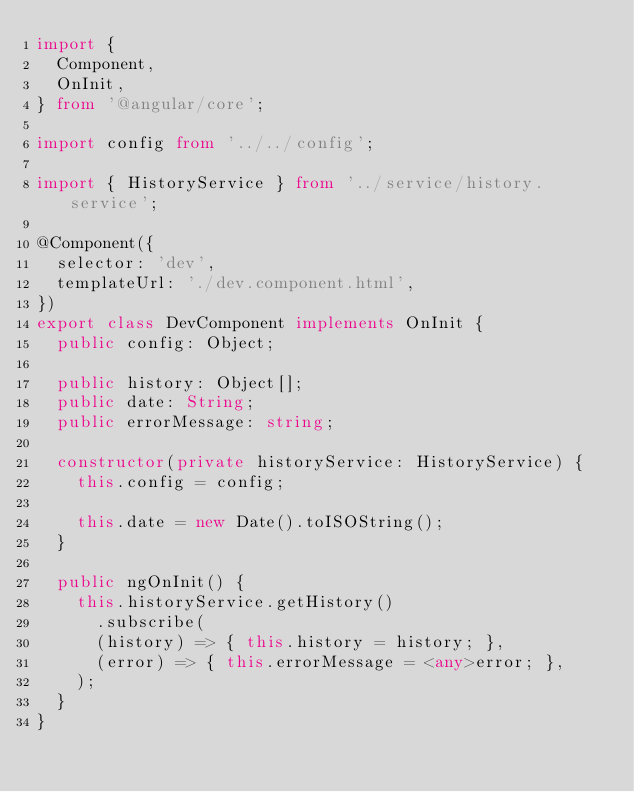<code> <loc_0><loc_0><loc_500><loc_500><_TypeScript_>import {
  Component,
  OnInit,
} from '@angular/core';

import config from '../../config';

import { HistoryService } from '../service/history.service';

@Component({
  selector: 'dev',
  templateUrl: './dev.component.html',
})
export class DevComponent implements OnInit {
  public config: Object;

  public history: Object[];
  public date: String;
  public errorMessage: string;

  constructor(private historyService: HistoryService) {
    this.config = config;

    this.date = new Date().toISOString();
  }

  public ngOnInit() {
    this.historyService.getHistory()
      .subscribe(
      (history) => { this.history = history; },
      (error) => { this.errorMessage = <any>error; },
    );
  }
}
</code> 